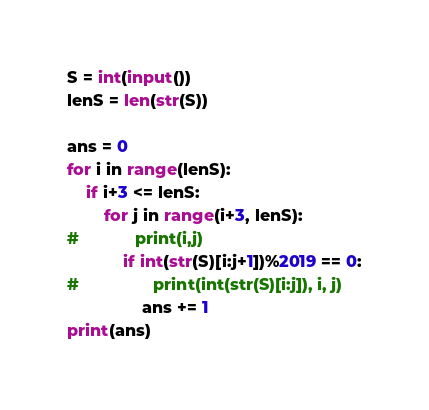<code> <loc_0><loc_0><loc_500><loc_500><_Python_>S = int(input())
lenS = len(str(S))

ans = 0
for i in range(lenS):
    if i+3 <= lenS:
        for j in range(i+3, lenS):
#            print(i,j)
            if int(str(S)[i:j+1])%2019 == 0:
#                print(int(str(S)[i:j]), i, j)
                ans += 1
print(ans)</code> 